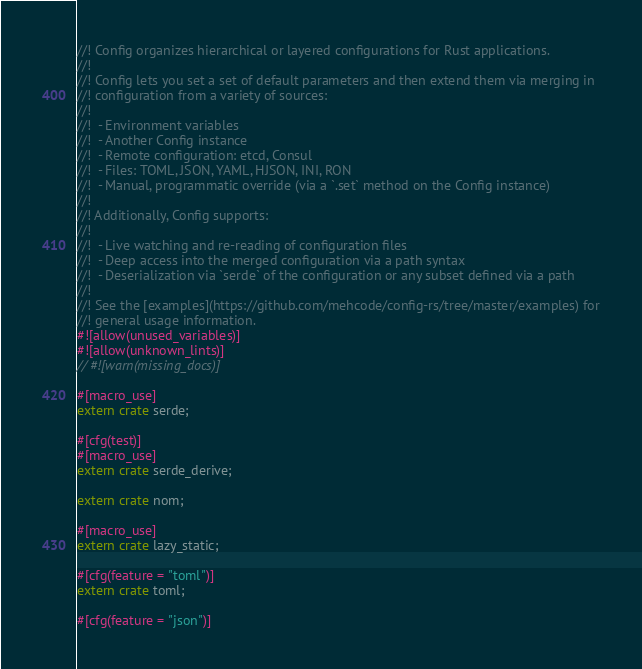Convert code to text. <code><loc_0><loc_0><loc_500><loc_500><_Rust_>//! Config organizes hierarchical or layered configurations for Rust applications.
//!
//! Config lets you set a set of default parameters and then extend them via merging in
//! configuration from a variety of sources:
//!
//!  - Environment variables
//!  - Another Config instance
//!  - Remote configuration: etcd, Consul
//!  - Files: TOML, JSON, YAML, HJSON, INI, RON
//!  - Manual, programmatic override (via a `.set` method on the Config instance)
//!
//! Additionally, Config supports:
//!
//!  - Live watching and re-reading of configuration files
//!  - Deep access into the merged configuration via a path syntax
//!  - Deserialization via `serde` of the configuration or any subset defined via a path
//!
//! See the [examples](https://github.com/mehcode/config-rs/tree/master/examples) for
//! general usage information.
#![allow(unused_variables)]
#![allow(unknown_lints)]
// #![warn(missing_docs)]

#[macro_use]
extern crate serde;

#[cfg(test)]
#[macro_use]
extern crate serde_derive;

extern crate nom;

#[macro_use]
extern crate lazy_static;

#[cfg(feature = "toml")]
extern crate toml;

#[cfg(feature = "json")]</code> 